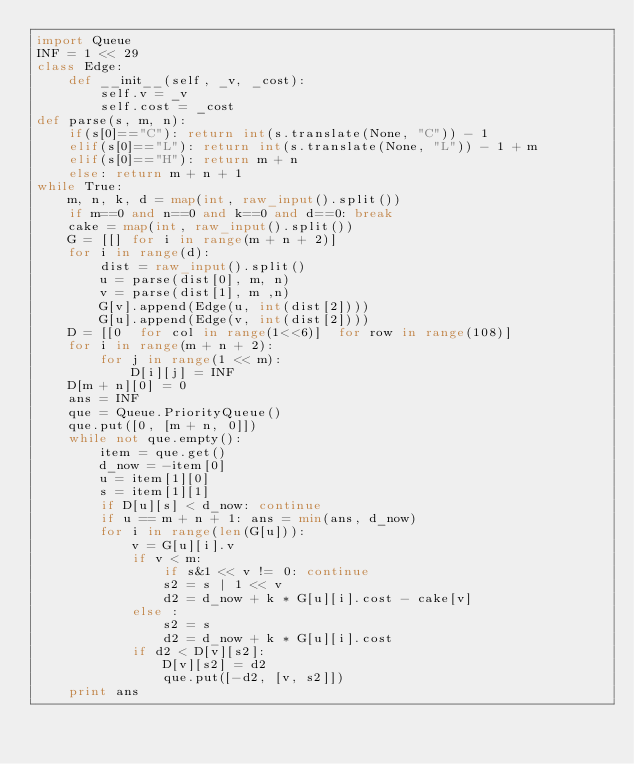<code> <loc_0><loc_0><loc_500><loc_500><_Python_>import Queue
INF = 1 << 29
class Edge:
    def __init__(self, _v, _cost):
        self.v = _v
        self.cost = _cost
def parse(s, m, n):
    if(s[0]=="C"): return int(s.translate(None, "C")) - 1
    elif(s[0]=="L"): return int(s.translate(None, "L")) - 1 + m
    elif(s[0]=="H"): return m + n 
    else: return m + n + 1
while True:
    m, n, k, d = map(int, raw_input().split())
    if m==0 and n==0 and k==0 and d==0: break
    cake = map(int, raw_input().split())
    G = [[] for i in range(m + n + 2)]
    for i in range(d):
        dist = raw_input().split()
        u = parse(dist[0], m, n)
        v = parse(dist[1], m ,n)
        G[v].append(Edge(u, int(dist[2])))
        G[u].append(Edge(v, int(dist[2])))
    D = [[0  for col in range(1<<6)]  for row in range(108)]
    for i in range(m + n + 2):
        for j in range(1 << m):
            D[i][j] = INF
    D[m + n][0] = 0
    ans = INF
    que = Queue.PriorityQueue()
    que.put([0, [m + n, 0]])
    while not que.empty():
        item = que.get()
        d_now = -item[0]
        u = item[1][0]
        s = item[1][1]
        if D[u][s] < d_now: continue
        if u == m + n + 1: ans = min(ans, d_now)
        for i in range(len(G[u])):
            v = G[u][i].v
            if v < m:
                if s&1 << v != 0: continue
                s2 = s | 1 << v
                d2 = d_now + k * G[u][i].cost - cake[v]
            else :
                s2 = s
                d2 = d_now + k * G[u][i].cost
            if d2 < D[v][s2]:
                D[v][s2] = d2
                que.put([-d2, [v, s2]])
    print ans</code> 